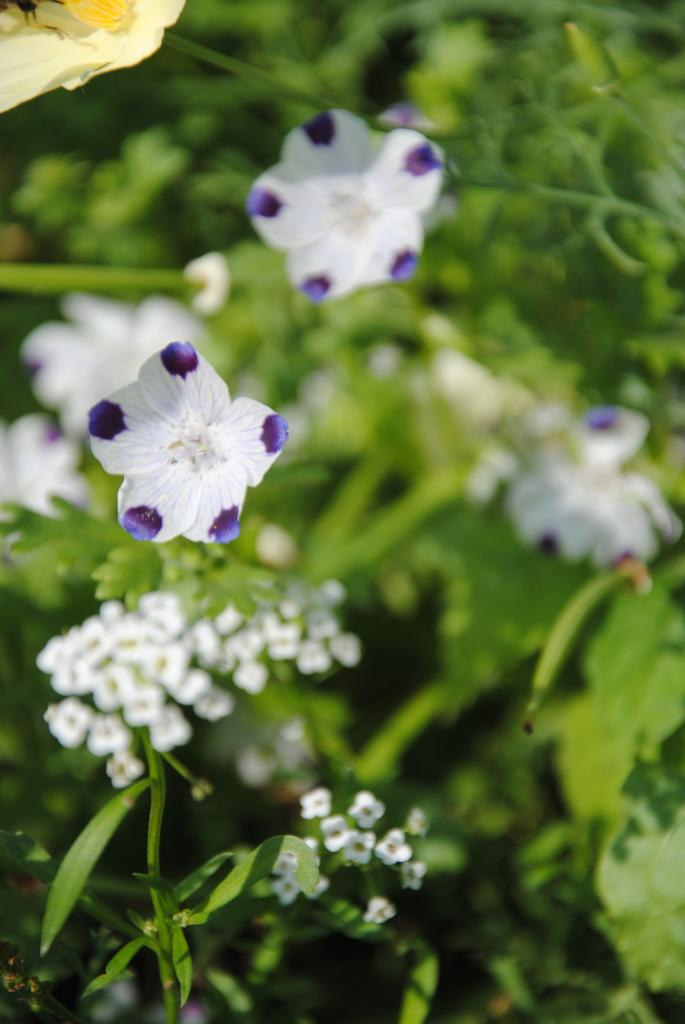What type of living organisms can be seen in the image? Plants can be seen in the image. What specific parts of the plants are visible? The plants have leaves and flowers. Can you describe the background of the image? The background of the image is blurry. How many waves can be seen crashing on the shore in the image? There are no waves present in the image; it features plants with leaves and flowers. What type of corn is growing in the image? There is no corn present in the image; it features plants with leaves and flowers. 